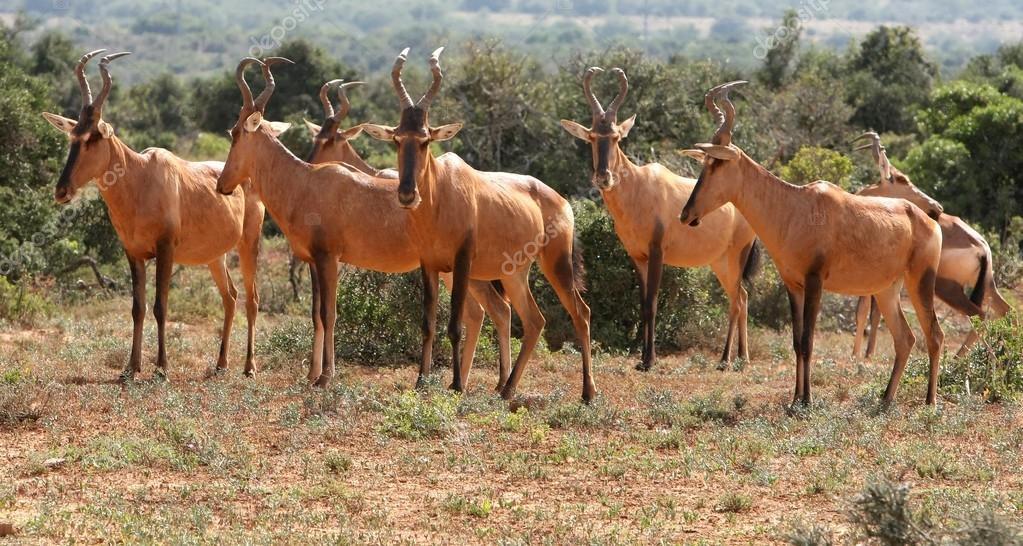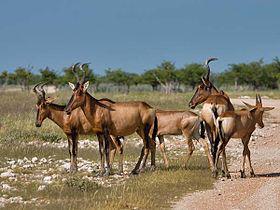The first image is the image on the left, the second image is the image on the right. Considering the images on both sides, is "The horned animals in one image are all standing with their rears showing." valid? Answer yes or no. No. 